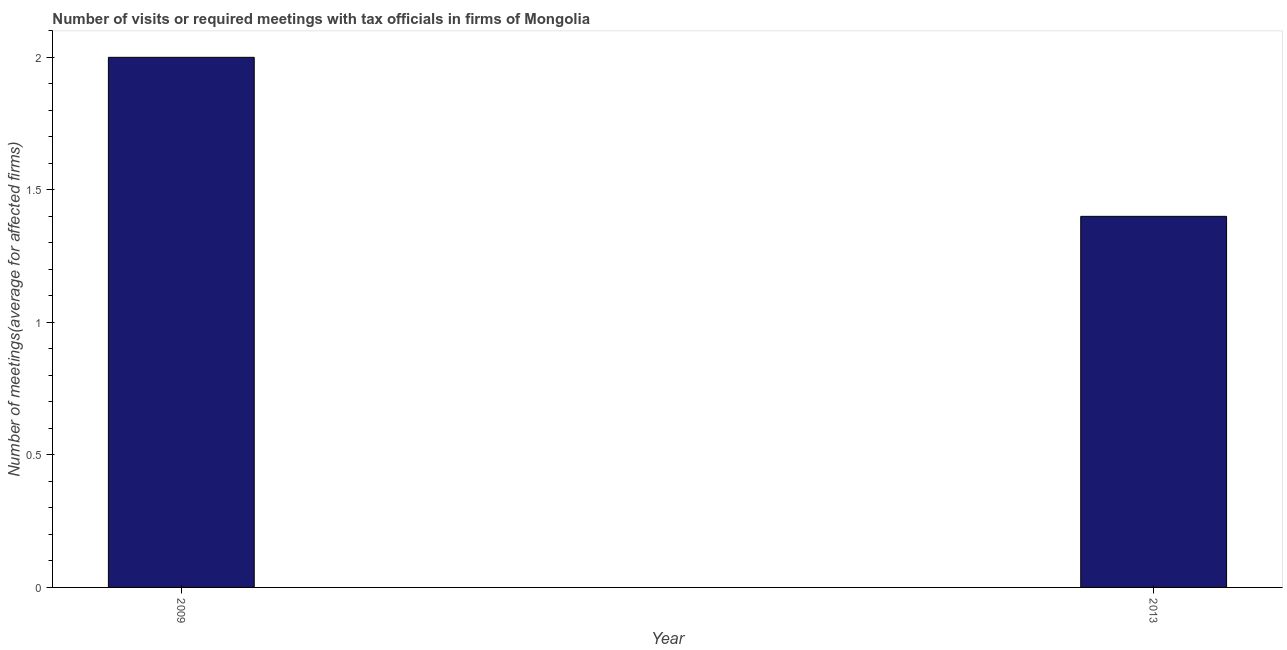Does the graph contain any zero values?
Provide a succinct answer. No. Does the graph contain grids?
Keep it short and to the point. No. What is the title of the graph?
Provide a short and direct response. Number of visits or required meetings with tax officials in firms of Mongolia. What is the label or title of the X-axis?
Keep it short and to the point. Year. What is the label or title of the Y-axis?
Give a very brief answer. Number of meetings(average for affected firms). In which year was the number of required meetings with tax officials maximum?
Your response must be concise. 2009. What is the difference between the number of required meetings with tax officials in 2009 and 2013?
Your response must be concise. 0.6. What is the median number of required meetings with tax officials?
Keep it short and to the point. 1.7. Do a majority of the years between 2009 and 2013 (inclusive) have number of required meetings with tax officials greater than 1.1 ?
Offer a very short reply. Yes. What is the ratio of the number of required meetings with tax officials in 2009 to that in 2013?
Your response must be concise. 1.43. Is the number of required meetings with tax officials in 2009 less than that in 2013?
Your answer should be compact. No. How many years are there in the graph?
Provide a short and direct response. 2. What is the difference between two consecutive major ticks on the Y-axis?
Your response must be concise. 0.5. What is the Number of meetings(average for affected firms) in 2013?
Provide a succinct answer. 1.4. What is the difference between the Number of meetings(average for affected firms) in 2009 and 2013?
Provide a short and direct response. 0.6. What is the ratio of the Number of meetings(average for affected firms) in 2009 to that in 2013?
Offer a terse response. 1.43. 